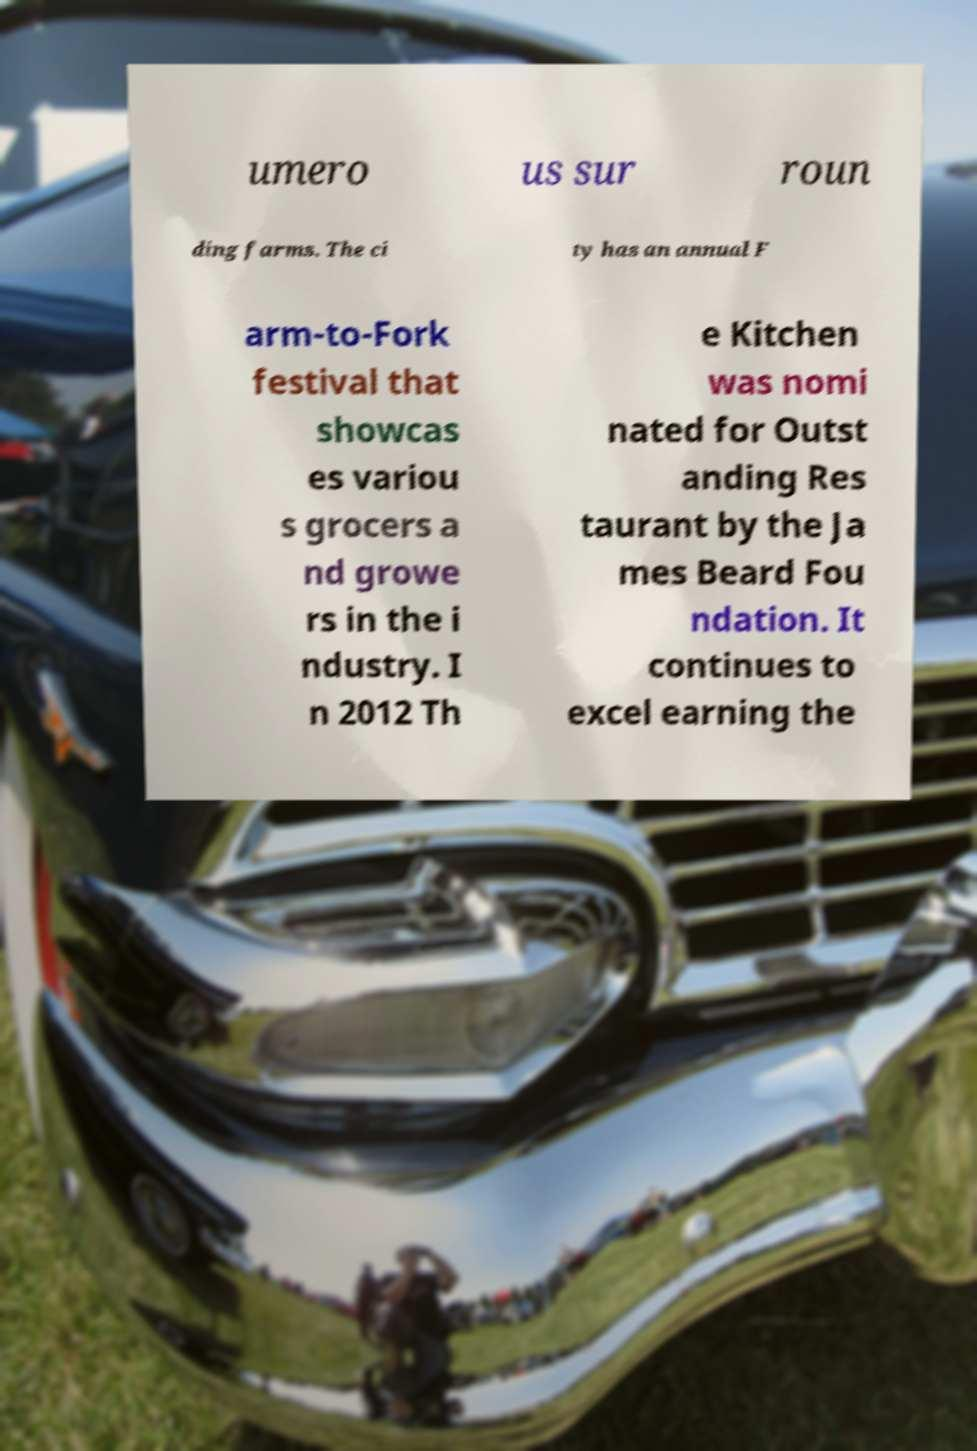Could you extract and type out the text from this image? umero us sur roun ding farms. The ci ty has an annual F arm-to-Fork festival that showcas es variou s grocers a nd growe rs in the i ndustry. I n 2012 Th e Kitchen was nomi nated for Outst anding Res taurant by the Ja mes Beard Fou ndation. It continues to excel earning the 